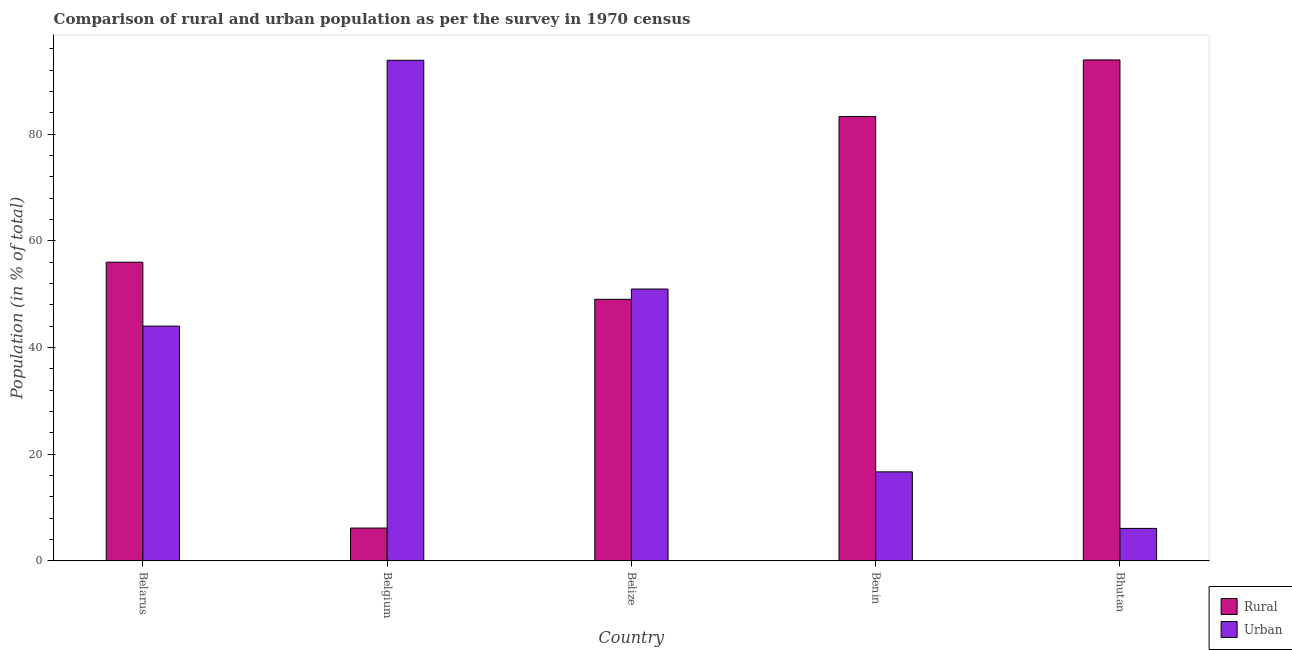How many different coloured bars are there?
Provide a succinct answer. 2. How many groups of bars are there?
Provide a short and direct response. 5. Are the number of bars per tick equal to the number of legend labels?
Your response must be concise. Yes. Are the number of bars on each tick of the X-axis equal?
Offer a very short reply. Yes. What is the label of the 3rd group of bars from the left?
Your answer should be compact. Belize. In how many cases, is the number of bars for a given country not equal to the number of legend labels?
Keep it short and to the point. 0. What is the rural population in Belize?
Offer a very short reply. 49.04. Across all countries, what is the maximum urban population?
Offer a very short reply. 93.84. Across all countries, what is the minimum urban population?
Make the answer very short. 6.09. In which country was the urban population minimum?
Give a very brief answer. Bhutan. What is the total rural population in the graph?
Your answer should be very brief. 288.4. What is the difference between the urban population in Belarus and that in Benin?
Keep it short and to the point. 27.32. What is the difference between the rural population in Belgium and the urban population in Bhutan?
Provide a succinct answer. 0.07. What is the average rural population per country?
Ensure brevity in your answer.  57.68. What is the difference between the urban population and rural population in Belgium?
Your answer should be very brief. 87.69. In how many countries, is the urban population greater than 40 %?
Offer a very short reply. 3. What is the ratio of the rural population in Belize to that in Benin?
Provide a short and direct response. 0.59. Is the rural population in Belarus less than that in Benin?
Make the answer very short. Yes. What is the difference between the highest and the second highest urban population?
Provide a succinct answer. 42.88. What is the difference between the highest and the lowest urban population?
Provide a succinct answer. 87.75. Is the sum of the rural population in Belgium and Bhutan greater than the maximum urban population across all countries?
Ensure brevity in your answer.  Yes. What does the 1st bar from the left in Bhutan represents?
Give a very brief answer. Rural. What does the 1st bar from the right in Belgium represents?
Ensure brevity in your answer.  Urban. How many bars are there?
Provide a short and direct response. 10. How many countries are there in the graph?
Provide a succinct answer. 5. What is the difference between two consecutive major ticks on the Y-axis?
Your answer should be compact. 20. Are the values on the major ticks of Y-axis written in scientific E-notation?
Make the answer very short. No. Does the graph contain any zero values?
Your response must be concise. No. Where does the legend appear in the graph?
Provide a short and direct response. Bottom right. How many legend labels are there?
Keep it short and to the point. 2. What is the title of the graph?
Your response must be concise. Comparison of rural and urban population as per the survey in 1970 census. Does "Under five" appear as one of the legend labels in the graph?
Offer a very short reply. No. What is the label or title of the X-axis?
Ensure brevity in your answer.  Country. What is the label or title of the Y-axis?
Provide a succinct answer. Population (in % of total). What is the Population (in % of total) of Rural in Belarus?
Your answer should be very brief. 55.99. What is the Population (in % of total) of Urban in Belarus?
Keep it short and to the point. 44.01. What is the Population (in % of total) of Rural in Belgium?
Ensure brevity in your answer.  6.16. What is the Population (in % of total) in Urban in Belgium?
Your answer should be very brief. 93.84. What is the Population (in % of total) of Rural in Belize?
Your answer should be compact. 49.04. What is the Population (in % of total) of Urban in Belize?
Ensure brevity in your answer.  50.96. What is the Population (in % of total) of Rural in Benin?
Provide a succinct answer. 83.31. What is the Population (in % of total) of Urban in Benin?
Ensure brevity in your answer.  16.69. What is the Population (in % of total) in Rural in Bhutan?
Keep it short and to the point. 93.91. What is the Population (in % of total) of Urban in Bhutan?
Keep it short and to the point. 6.09. Across all countries, what is the maximum Population (in % of total) in Rural?
Your response must be concise. 93.91. Across all countries, what is the maximum Population (in % of total) in Urban?
Provide a succinct answer. 93.84. Across all countries, what is the minimum Population (in % of total) of Rural?
Your answer should be very brief. 6.16. Across all countries, what is the minimum Population (in % of total) in Urban?
Your response must be concise. 6.09. What is the total Population (in % of total) of Rural in the graph?
Provide a succinct answer. 288.4. What is the total Population (in % of total) of Urban in the graph?
Provide a succinct answer. 211.6. What is the difference between the Population (in % of total) of Rural in Belarus and that in Belgium?
Offer a very short reply. 49.83. What is the difference between the Population (in % of total) of Urban in Belarus and that in Belgium?
Provide a succinct answer. -49.83. What is the difference between the Population (in % of total) in Rural in Belarus and that in Belize?
Provide a short and direct response. 6.95. What is the difference between the Population (in % of total) of Urban in Belarus and that in Belize?
Offer a very short reply. -6.95. What is the difference between the Population (in % of total) of Rural in Belarus and that in Benin?
Offer a very short reply. -27.32. What is the difference between the Population (in % of total) of Urban in Belarus and that in Benin?
Make the answer very short. 27.32. What is the difference between the Population (in % of total) of Rural in Belarus and that in Bhutan?
Make the answer very short. -37.92. What is the difference between the Population (in % of total) in Urban in Belarus and that in Bhutan?
Give a very brief answer. 37.92. What is the difference between the Population (in % of total) of Rural in Belgium and that in Belize?
Make the answer very short. -42.88. What is the difference between the Population (in % of total) in Urban in Belgium and that in Belize?
Your answer should be compact. 42.88. What is the difference between the Population (in % of total) of Rural in Belgium and that in Benin?
Your response must be concise. -77.15. What is the difference between the Population (in % of total) in Urban in Belgium and that in Benin?
Make the answer very short. 77.15. What is the difference between the Population (in % of total) in Rural in Belgium and that in Bhutan?
Provide a succinct answer. -87.75. What is the difference between the Population (in % of total) of Urban in Belgium and that in Bhutan?
Your answer should be compact. 87.75. What is the difference between the Population (in % of total) of Rural in Belize and that in Benin?
Provide a succinct answer. -34.27. What is the difference between the Population (in % of total) in Urban in Belize and that in Benin?
Give a very brief answer. 34.27. What is the difference between the Population (in % of total) in Rural in Belize and that in Bhutan?
Keep it short and to the point. -44.87. What is the difference between the Population (in % of total) of Urban in Belize and that in Bhutan?
Your answer should be compact. 44.87. What is the difference between the Population (in % of total) of Rural in Benin and that in Bhutan?
Provide a short and direct response. -10.6. What is the difference between the Population (in % of total) of Urban in Benin and that in Bhutan?
Keep it short and to the point. 10.6. What is the difference between the Population (in % of total) in Rural in Belarus and the Population (in % of total) in Urban in Belgium?
Your answer should be compact. -37.85. What is the difference between the Population (in % of total) in Rural in Belarus and the Population (in % of total) in Urban in Belize?
Provide a succinct answer. 5.03. What is the difference between the Population (in % of total) in Rural in Belarus and the Population (in % of total) in Urban in Benin?
Provide a short and direct response. 39.3. What is the difference between the Population (in % of total) in Rural in Belarus and the Population (in % of total) in Urban in Bhutan?
Your answer should be very brief. 49.9. What is the difference between the Population (in % of total) of Rural in Belgium and the Population (in % of total) of Urban in Belize?
Offer a terse response. -44.81. What is the difference between the Population (in % of total) in Rural in Belgium and the Population (in % of total) in Urban in Benin?
Provide a succinct answer. -10.53. What is the difference between the Population (in % of total) of Rural in Belgium and the Population (in % of total) of Urban in Bhutan?
Your answer should be very brief. 0.07. What is the difference between the Population (in % of total) in Rural in Belize and the Population (in % of total) in Urban in Benin?
Give a very brief answer. 32.35. What is the difference between the Population (in % of total) in Rural in Belize and the Population (in % of total) in Urban in Bhutan?
Your answer should be compact. 42.95. What is the difference between the Population (in % of total) in Rural in Benin and the Population (in % of total) in Urban in Bhutan?
Your answer should be compact. 77.22. What is the average Population (in % of total) of Rural per country?
Offer a terse response. 57.68. What is the average Population (in % of total) of Urban per country?
Make the answer very short. 42.32. What is the difference between the Population (in % of total) of Rural and Population (in % of total) of Urban in Belarus?
Offer a very short reply. 11.98. What is the difference between the Population (in % of total) of Rural and Population (in % of total) of Urban in Belgium?
Provide a succinct answer. -87.69. What is the difference between the Population (in % of total) in Rural and Population (in % of total) in Urban in Belize?
Ensure brevity in your answer.  -1.93. What is the difference between the Population (in % of total) of Rural and Population (in % of total) of Urban in Benin?
Your answer should be very brief. 66.62. What is the difference between the Population (in % of total) of Rural and Population (in % of total) of Urban in Bhutan?
Ensure brevity in your answer.  87.82. What is the ratio of the Population (in % of total) of Rural in Belarus to that in Belgium?
Offer a terse response. 9.09. What is the ratio of the Population (in % of total) of Urban in Belarus to that in Belgium?
Make the answer very short. 0.47. What is the ratio of the Population (in % of total) of Rural in Belarus to that in Belize?
Offer a very short reply. 1.14. What is the ratio of the Population (in % of total) of Urban in Belarus to that in Belize?
Offer a terse response. 0.86. What is the ratio of the Population (in % of total) of Rural in Belarus to that in Benin?
Give a very brief answer. 0.67. What is the ratio of the Population (in % of total) in Urban in Belarus to that in Benin?
Your response must be concise. 2.64. What is the ratio of the Population (in % of total) in Rural in Belarus to that in Bhutan?
Make the answer very short. 0.6. What is the ratio of the Population (in % of total) of Urban in Belarus to that in Bhutan?
Offer a terse response. 7.23. What is the ratio of the Population (in % of total) in Rural in Belgium to that in Belize?
Provide a succinct answer. 0.13. What is the ratio of the Population (in % of total) in Urban in Belgium to that in Belize?
Give a very brief answer. 1.84. What is the ratio of the Population (in % of total) in Rural in Belgium to that in Benin?
Make the answer very short. 0.07. What is the ratio of the Population (in % of total) of Urban in Belgium to that in Benin?
Offer a very short reply. 5.62. What is the ratio of the Population (in % of total) in Rural in Belgium to that in Bhutan?
Provide a succinct answer. 0.07. What is the ratio of the Population (in % of total) of Urban in Belgium to that in Bhutan?
Provide a short and direct response. 15.41. What is the ratio of the Population (in % of total) in Rural in Belize to that in Benin?
Your answer should be very brief. 0.59. What is the ratio of the Population (in % of total) of Urban in Belize to that in Benin?
Give a very brief answer. 3.05. What is the ratio of the Population (in % of total) in Rural in Belize to that in Bhutan?
Make the answer very short. 0.52. What is the ratio of the Population (in % of total) in Urban in Belize to that in Bhutan?
Give a very brief answer. 8.37. What is the ratio of the Population (in % of total) in Rural in Benin to that in Bhutan?
Offer a very short reply. 0.89. What is the ratio of the Population (in % of total) of Urban in Benin to that in Bhutan?
Provide a succinct answer. 2.74. What is the difference between the highest and the second highest Population (in % of total) in Rural?
Give a very brief answer. 10.6. What is the difference between the highest and the second highest Population (in % of total) in Urban?
Your response must be concise. 42.88. What is the difference between the highest and the lowest Population (in % of total) of Rural?
Make the answer very short. 87.75. What is the difference between the highest and the lowest Population (in % of total) of Urban?
Offer a very short reply. 87.75. 